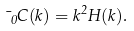<formula> <loc_0><loc_0><loc_500><loc_500>\mu _ { 0 } C ( k ) = k ^ { 2 } H ( k ) .</formula> 